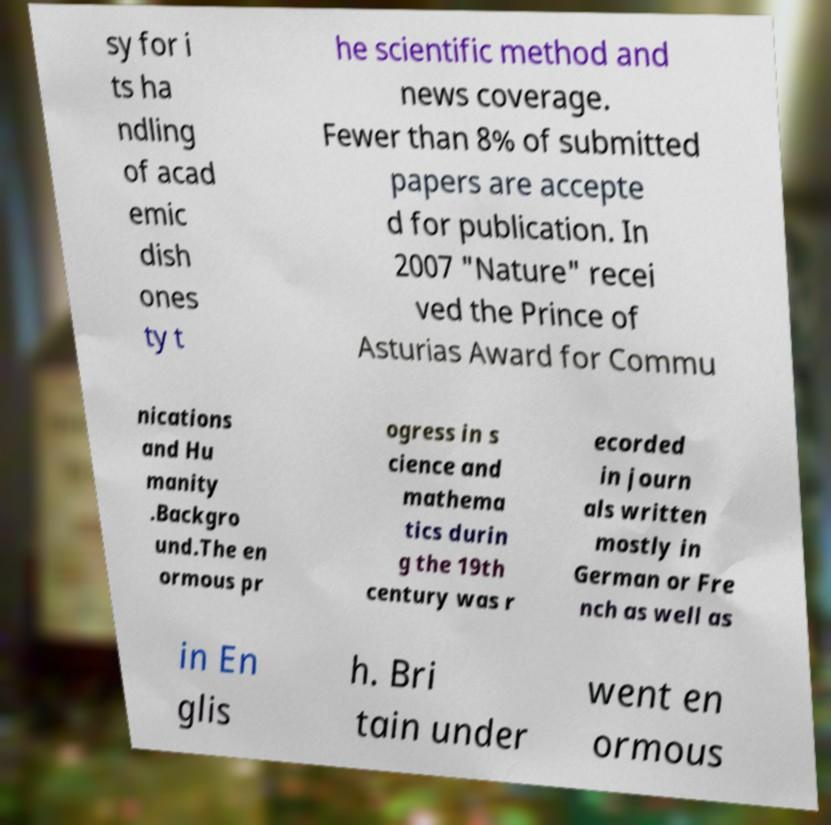For documentation purposes, I need the text within this image transcribed. Could you provide that? sy for i ts ha ndling of acad emic dish ones ty t he scientific method and news coverage. Fewer than 8% of submitted papers are accepte d for publication. In 2007 "Nature" recei ved the Prince of Asturias Award for Commu nications and Hu manity .Backgro und.The en ormous pr ogress in s cience and mathema tics durin g the 19th century was r ecorded in journ als written mostly in German or Fre nch as well as in En glis h. Bri tain under went en ormous 